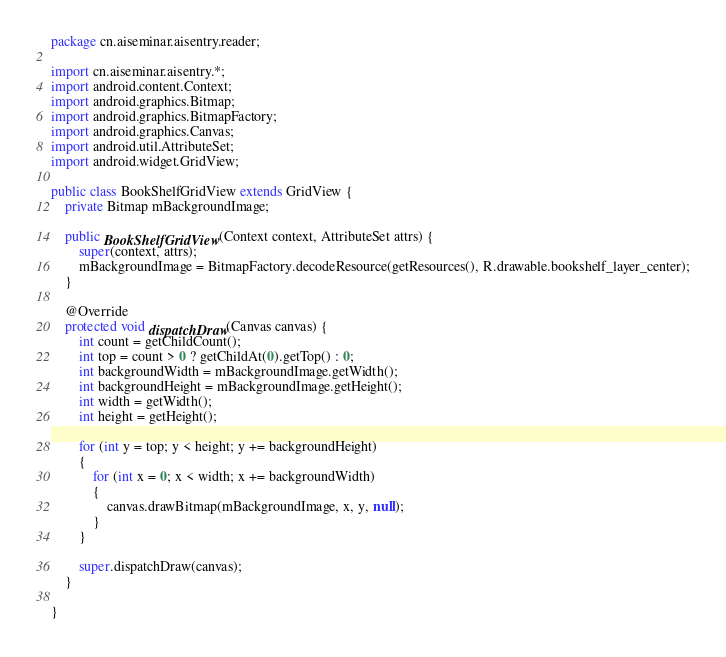Convert code to text. <code><loc_0><loc_0><loc_500><loc_500><_Java_>package cn.aiseminar.aisentry.reader;

import cn.aiseminar.aisentry.*;
import android.content.Context;
import android.graphics.Bitmap;
import android.graphics.BitmapFactory;
import android.graphics.Canvas;
import android.util.AttributeSet;
import android.widget.GridView;

public class BookShelfGridView extends GridView {
	private Bitmap mBackgroundImage;

	public BookShelfGridView(Context context, AttributeSet attrs) {
		super(context, attrs);
		mBackgroundImage = BitmapFactory.decodeResource(getResources(), R.drawable.bookshelf_layer_center);
	}

	@Override
	protected void dispatchDraw(Canvas canvas) {
		int count = getChildCount();
		int top = count > 0 ? getChildAt(0).getTop() : 0;
		int backgroundWidth = mBackgroundImage.getWidth();
		int backgroundHeight = mBackgroundImage.getHeight();
		int width = getWidth();
		int height = getHeight();
		
		for (int y = top; y < height; y += backgroundHeight)
		{
			for (int x = 0; x < width; x += backgroundWidth)
			{
				canvas.drawBitmap(mBackgroundImage, x, y, null);
			}
		}
		
		super.dispatchDraw(canvas);
	}

}
</code> 